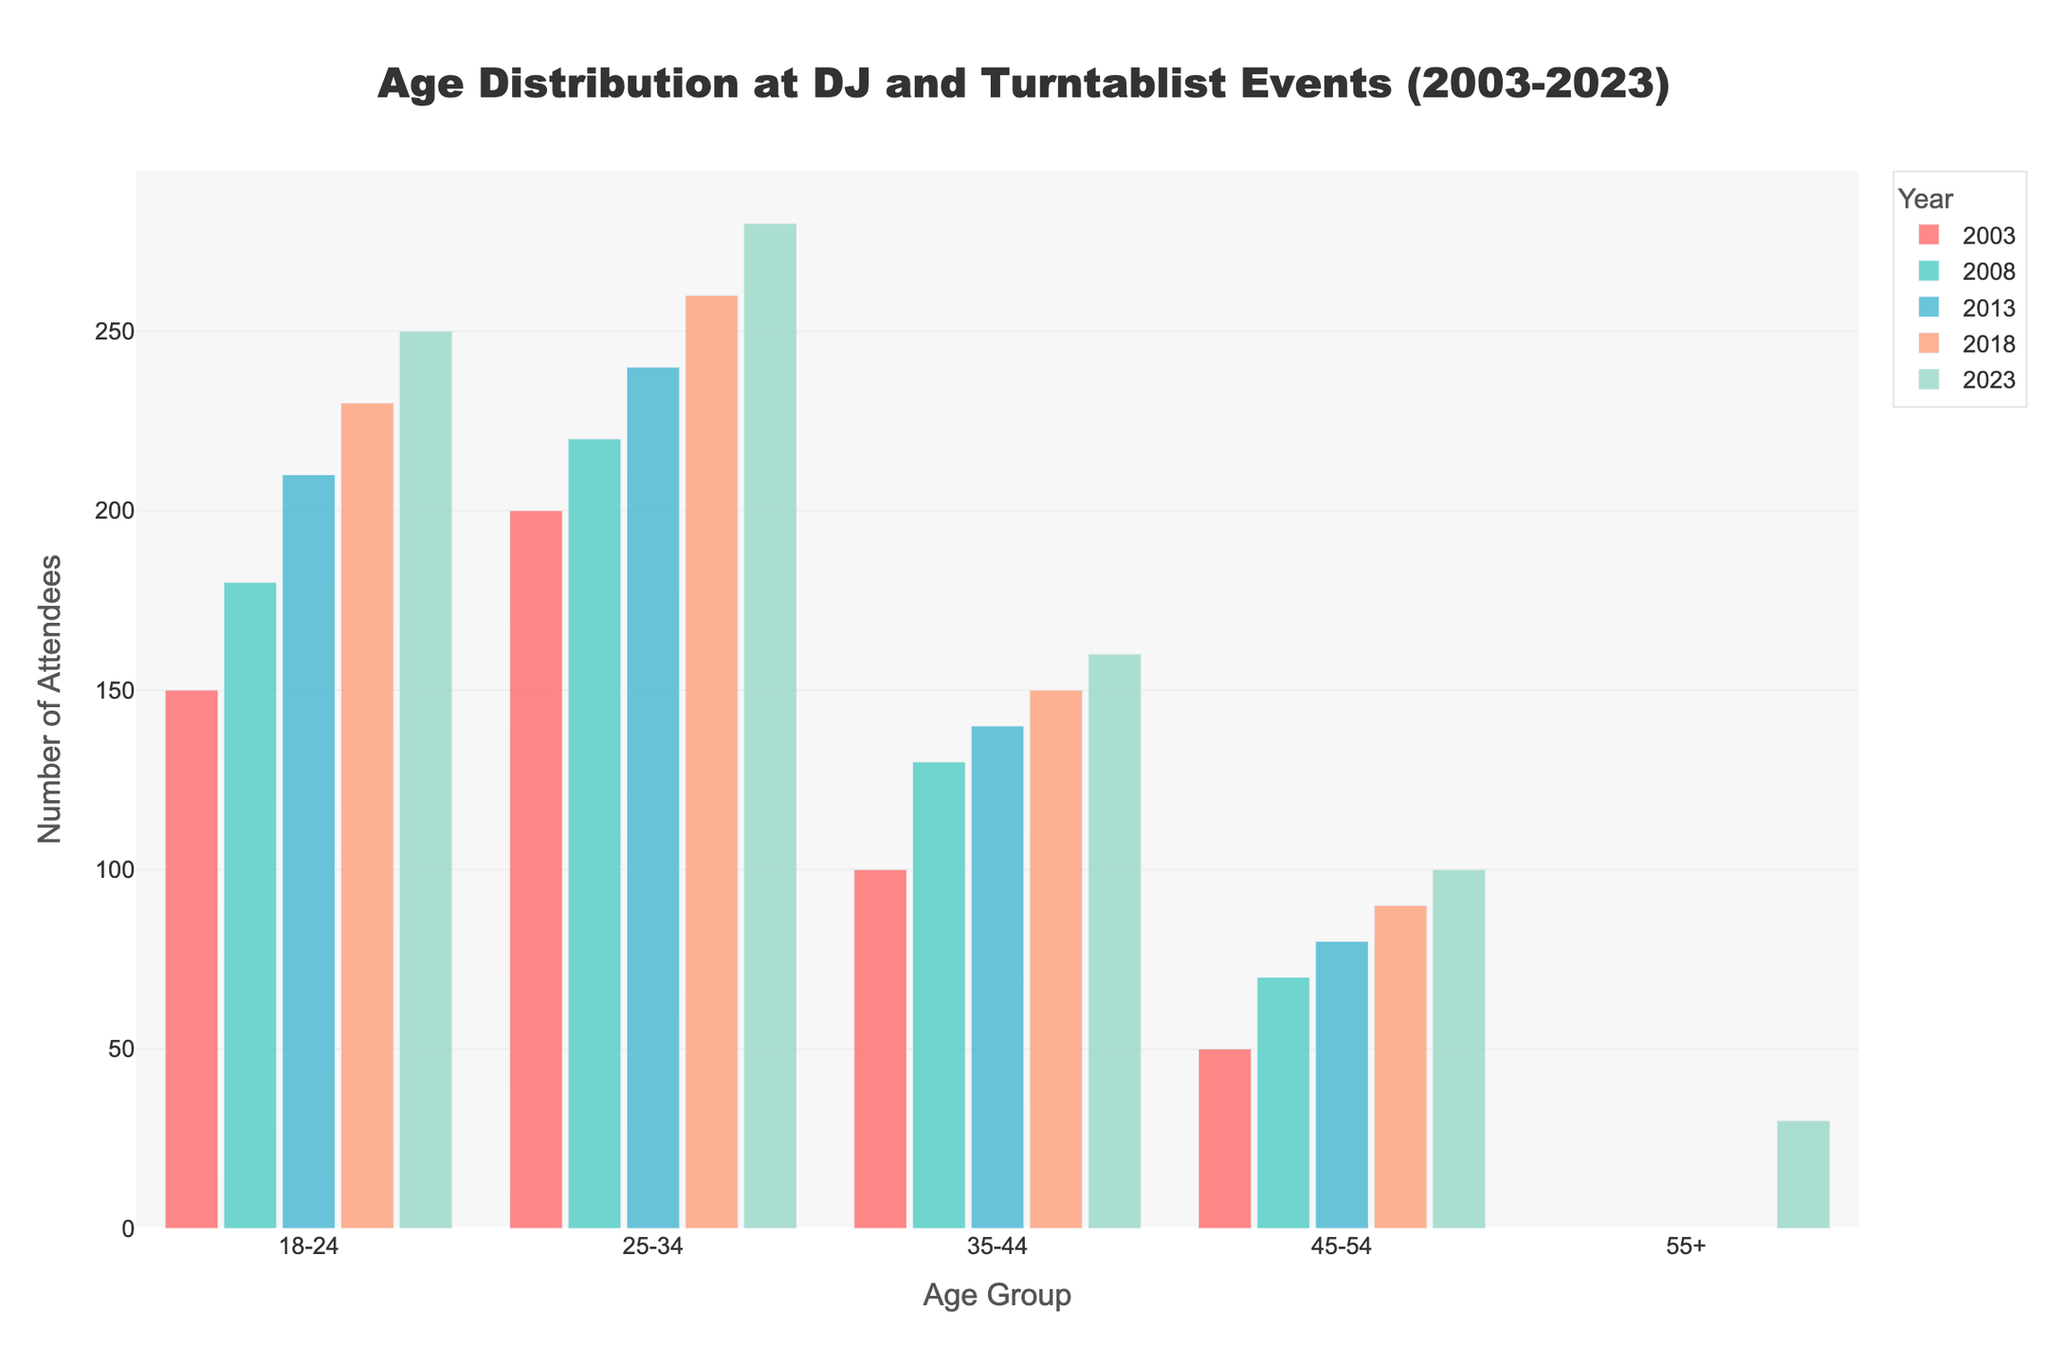What is the title of the plot? Look at the top center of the plot where the main heading is displayed. The title indicates the main topic or summary of the data being visualized.
Answer: Age Distribution at DJ and Turntablist Events (2003-2023) Which year had the highest number of attendees in the 18-24 age group? Examine the bars corresponding to the 18-24 age group across different years, focusing on their heights to determine which is tallest.
Answer: 2023 What is the attendee count for the 25-34 age group in 2008? Find the bar labeled 2008 and corresponding to the 25-34 age group, then read the height which represents the count.
Answer: 220 Compare the number of attendees aged 45-54 in 2003 and 2023. Which year had more? Look at the bars corresponding to the 45-54 age group for both 2003 and 2023, then compare their heights.
Answer: 2023 How did the attendance of the 35-44 age group change from 2003 to 2023? Check the bar height for the 35-44 age group in both 2003 and 2023, then calculate the difference.
Answer: Increased by 60 What is the trend of the 18-24 age group's attendance from 2003 to 2023? Track the heights of the bars for the 18-24 age group over the years and observe if they increase or decrease.
Answer: Increasing Which age group was added in the latest year, 2023? Scan the x-axis labels to see which new age group appears in 2023 that is not present in earlier years.
Answer: 55+ What is the average attendance for the 45-54 age group over the years provided? Add the counts for the 45-54 age group across all years and divide by the number of years data is available for.
Answer: (50 + 70 + 80 + 90 + 100) / 5 = 78 Is the 25-34 age group's attendance higher in 2008 or 2018? Compare the heights of the bars for the 25-34 age group for the years 2008 and 2018.
Answer: 2018 Which age group had the lowest attendance in 2023? Check the heights of the bars for the 2023 year and find the shortest one.
Answer: 55+ 